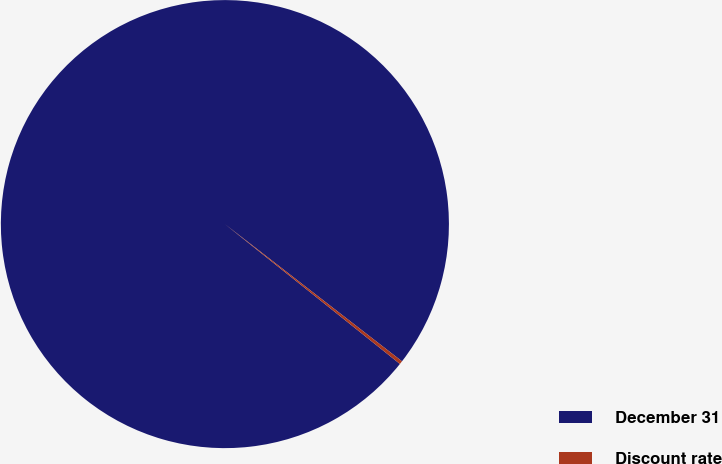Convert chart to OTSL. <chart><loc_0><loc_0><loc_500><loc_500><pie_chart><fcel>December 31<fcel>Discount rate<nl><fcel>99.76%<fcel>0.24%<nl></chart> 